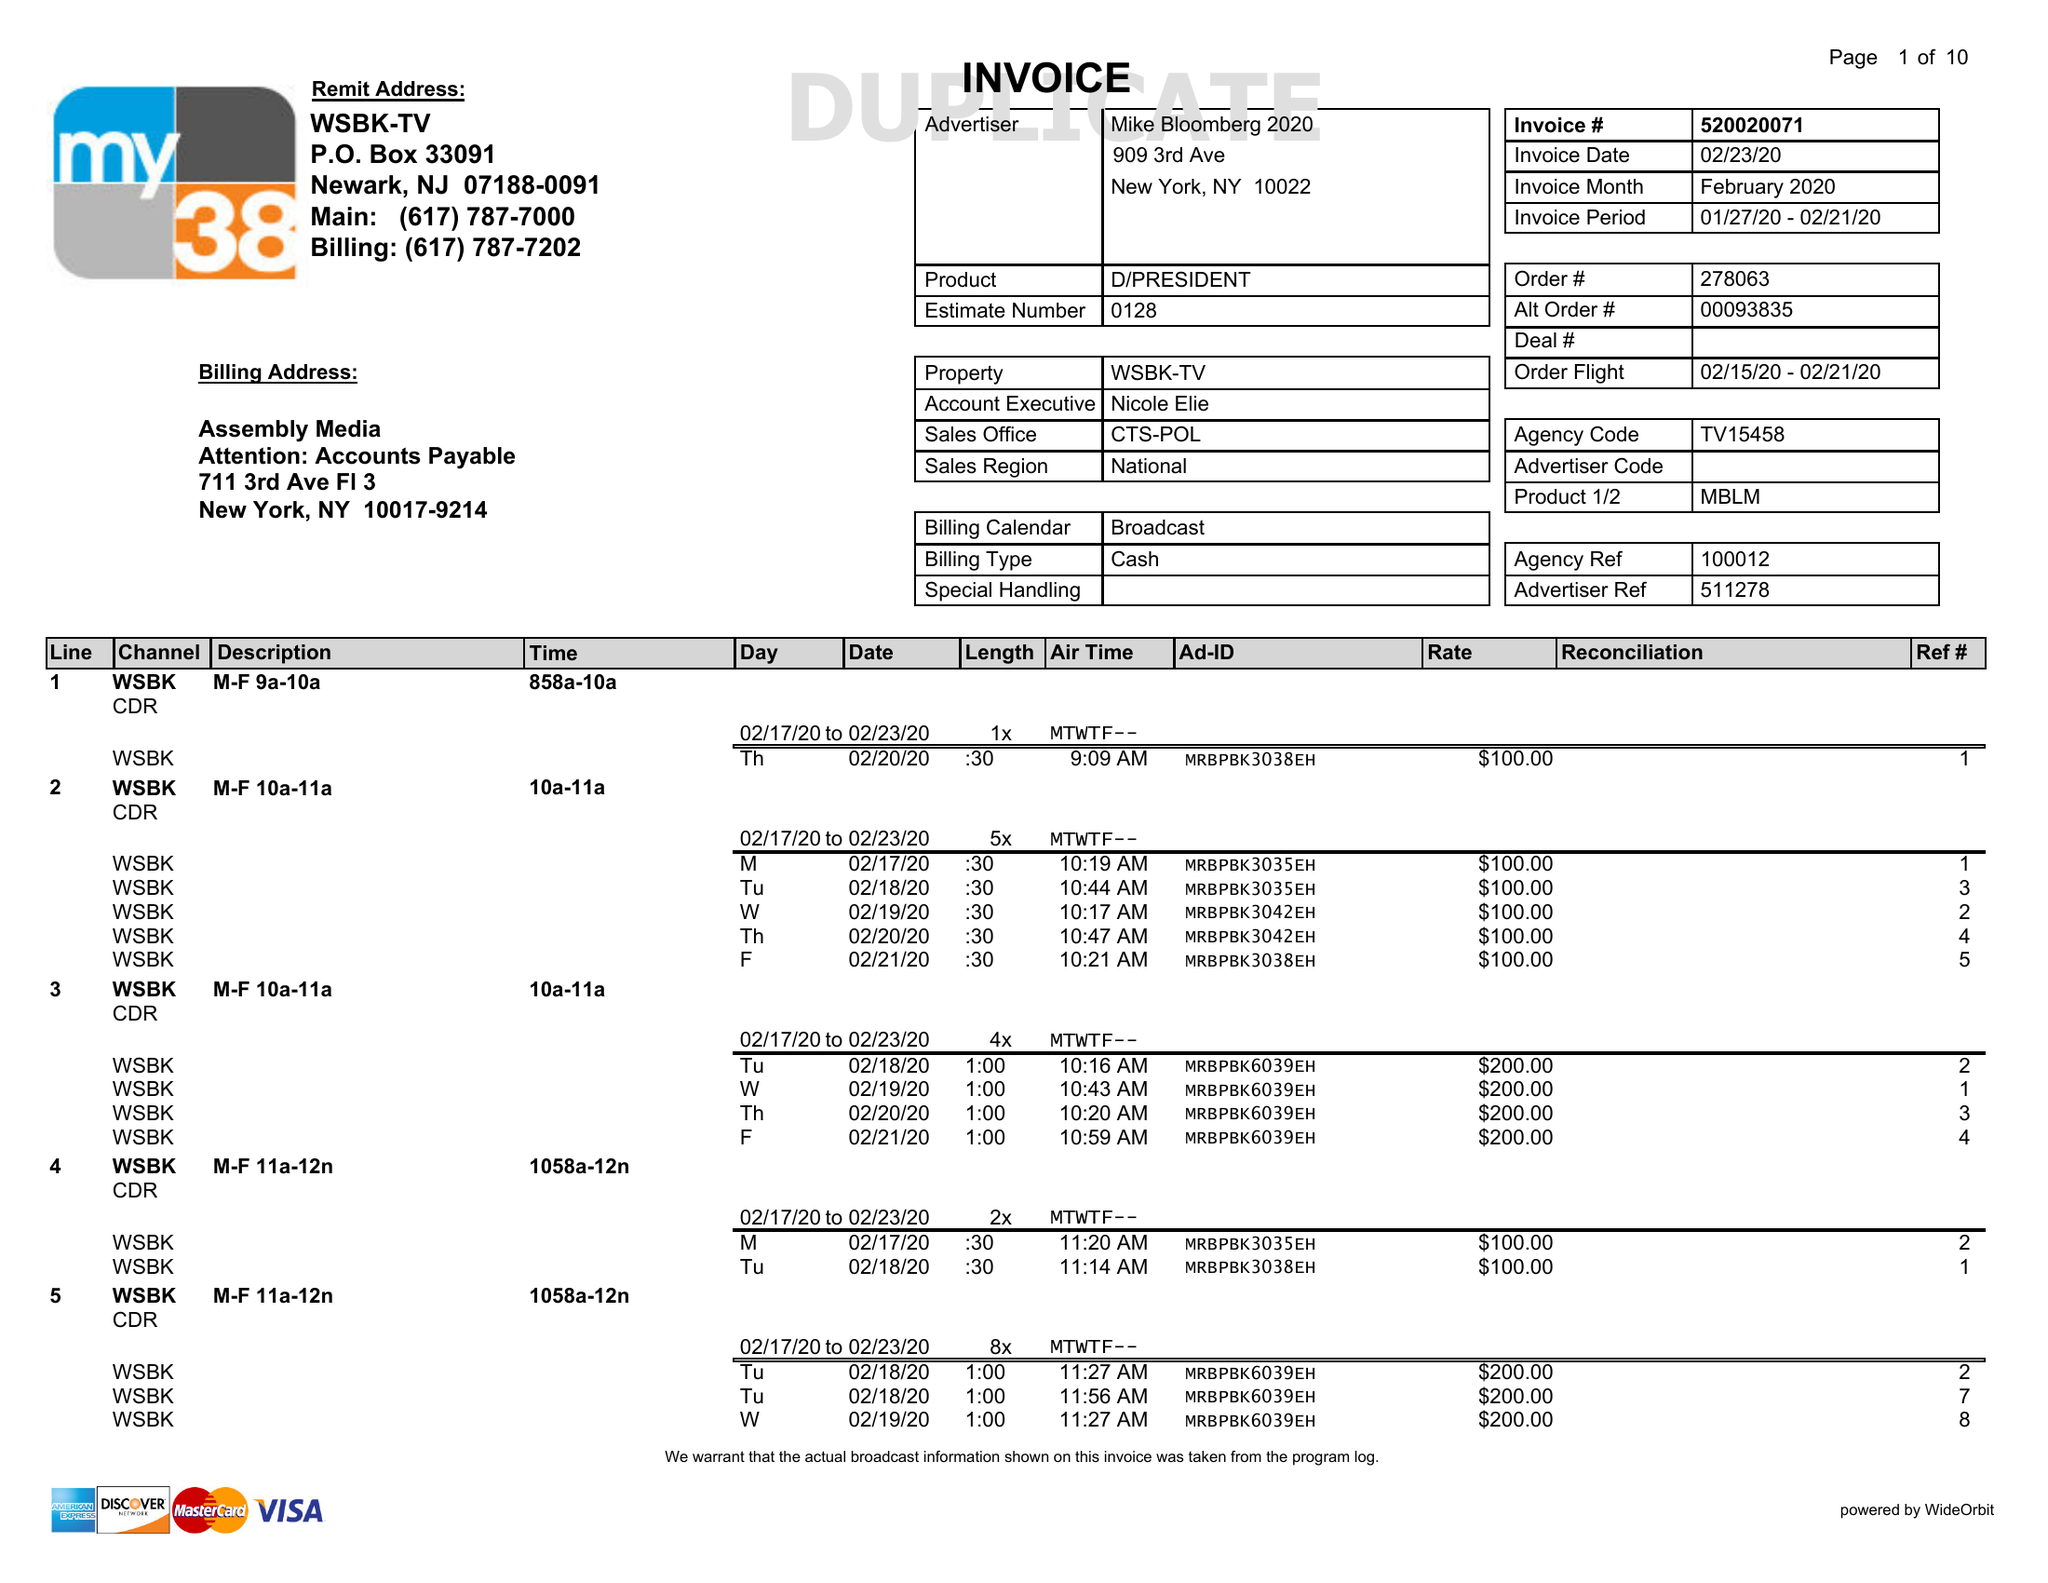What is the value for the contract_num?
Answer the question using a single word or phrase. 520020071 